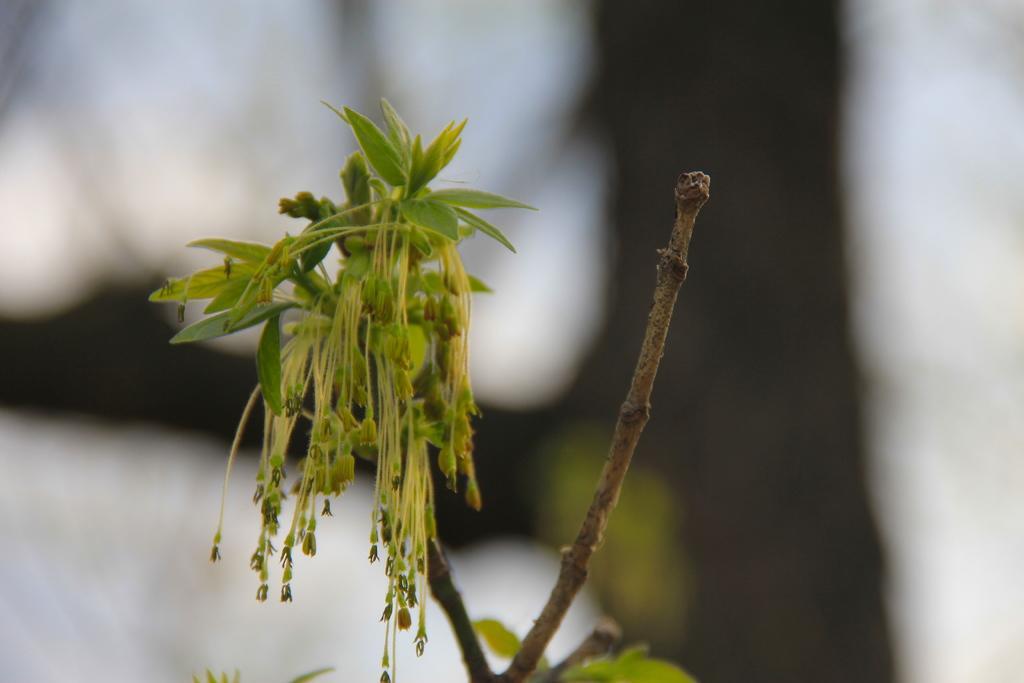Could you give a brief overview of what you see in this image? In this image we can see a houseplant. 